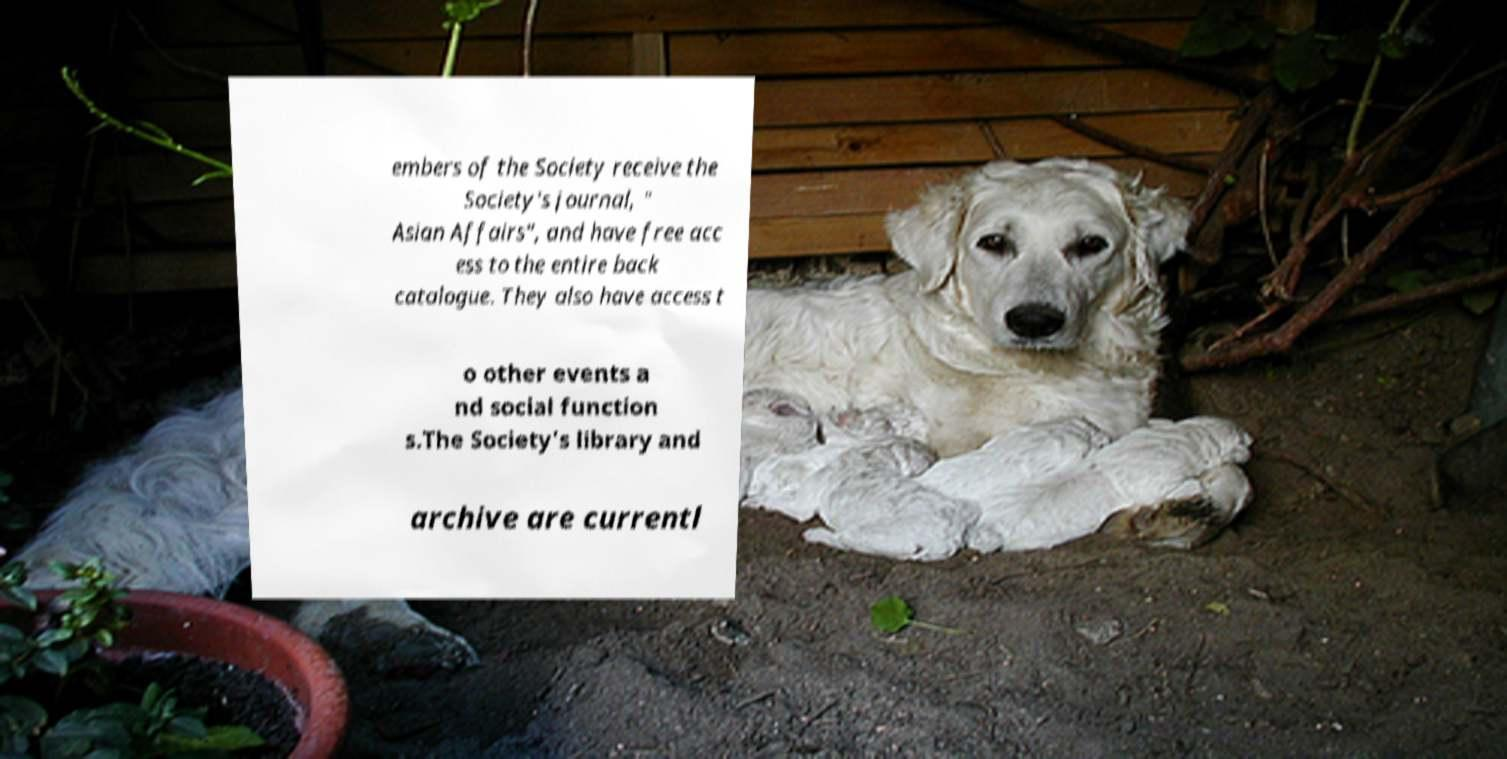I need the written content from this picture converted into text. Can you do that? embers of the Society receive the Society's journal, " Asian Affairs", and have free acc ess to the entire back catalogue. They also have access t o other events a nd social function s.The Society's library and archive are currentl 